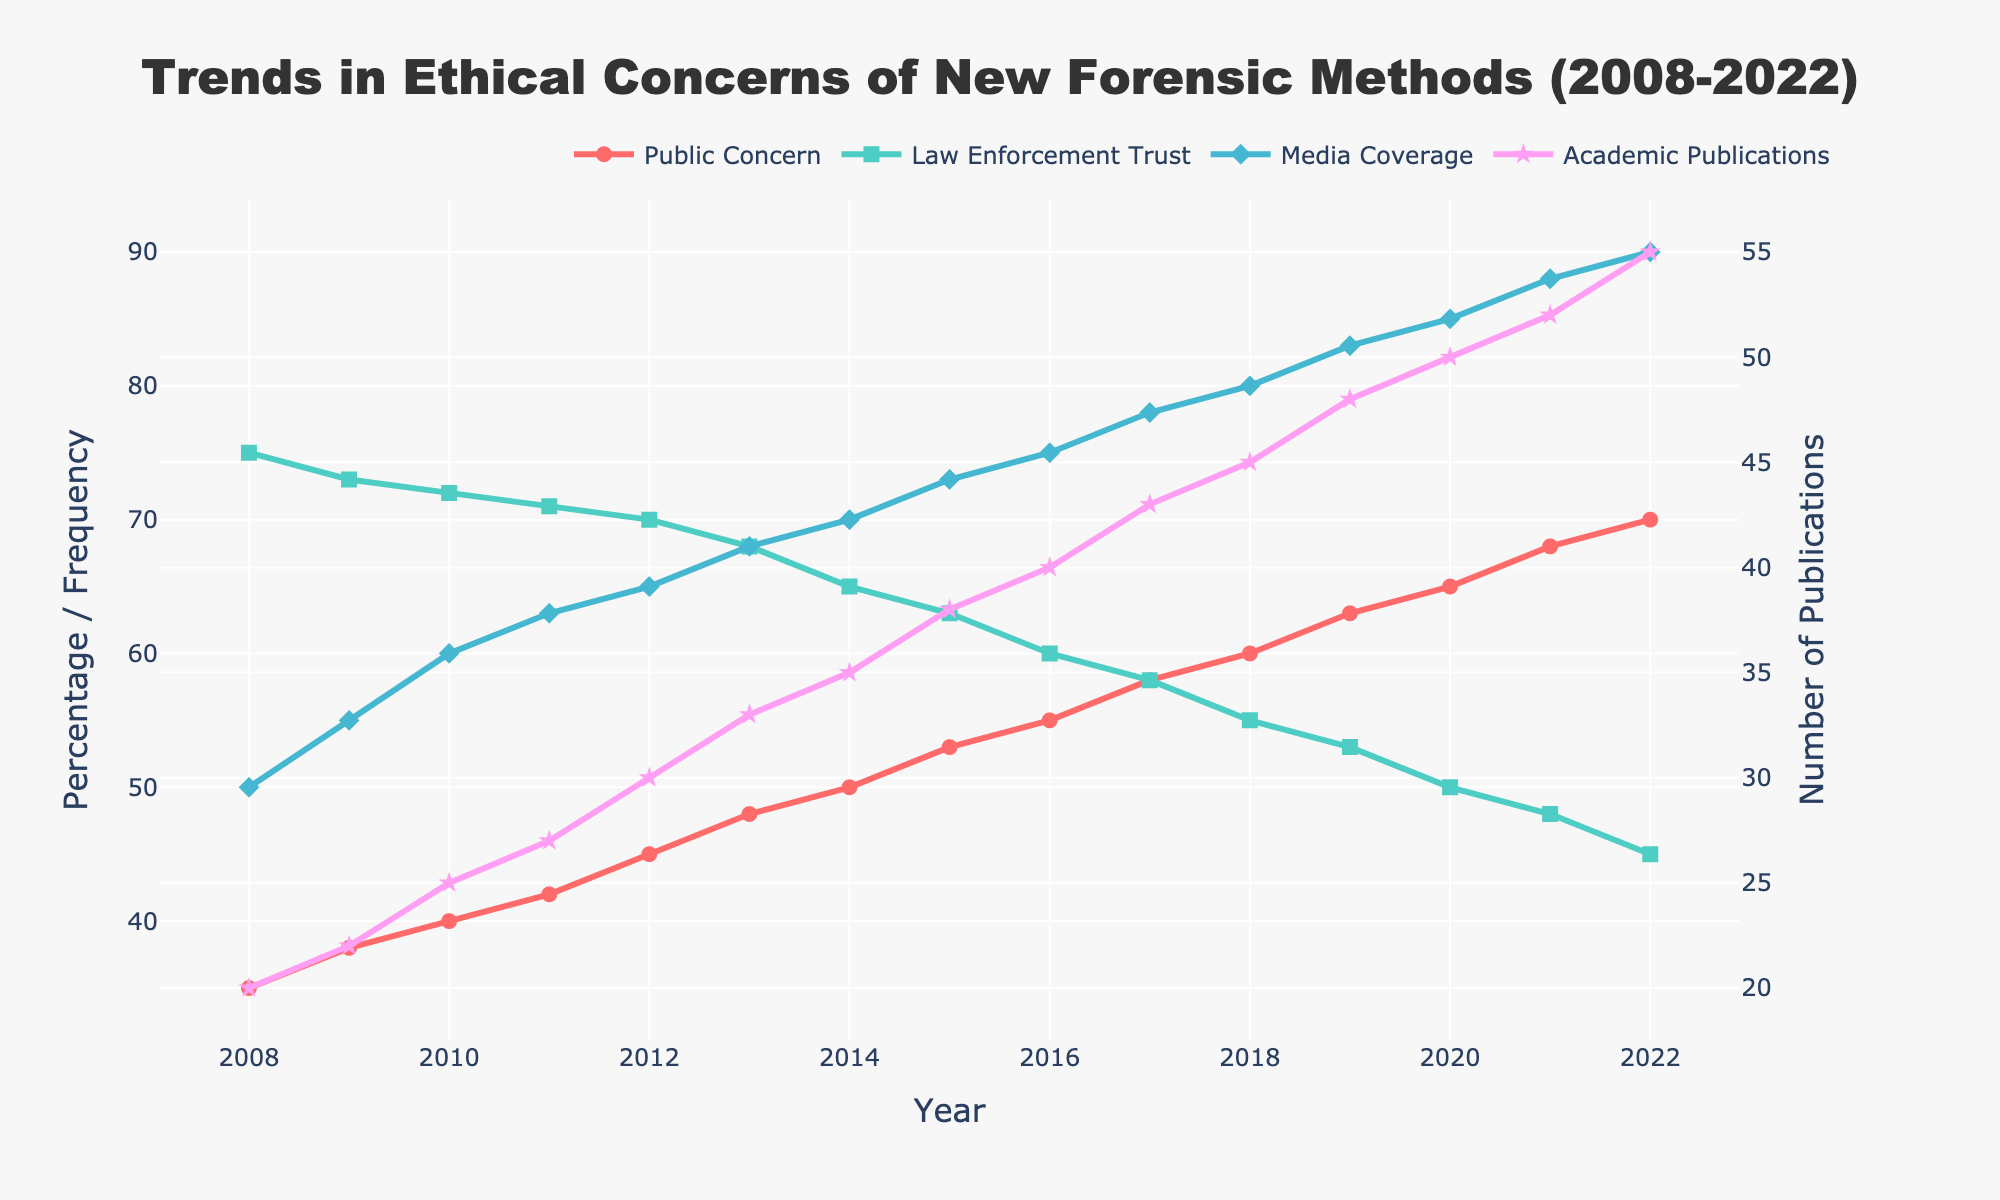what is the title of the plot? The title is usually located at the top center of the figure and briefly describes the plot's content. The title in this figure reads "Trends in Ethical Concerns of New Forensic Methods (2008-2022)."
Answer: Trends in Ethical Concerns of New Forensic Methods (2008-2022) what colors represent the different data series? Colors help distinguish different data series. The colors used are Red for Public Concern, Teal for Law Enforcement Trust, Light Blue for Media Coverage, and Pink for Academic Publications.
Answer: Red, Teal, Light Blue, and Pink what is the percentage of Law Enforcement Trust in 2020? Find the data point at "2020" on the x-axis and look at its corresponding value on the "Law Enforcement Trust" line, which is around 50.
Answer: 50 how did Media Coverage Frequency change from 2010 to 2015? From 2010 to 2015, identify the Media Coverage data points and calculate the difference: 55 in 2010 and 73 in 2015, so it increased by 18.
Answer: Increased by 18 how do General Public Concern and Law Enforcement Trust trends compare over the years? The General Public Concern shows an upward trend from 35 in 2008 to 70 in 2022, while Law Enforcement Trust shows a downward trend from 75 in 2008 to 45 in 2022.
Answer: Public Concern upward, Trust downward what is the average number of Academic Publications from 2008 to 2022? Sum all the values for Academic Publications from 2008 to 2022 and divide by the number of years (15). Sum of values is 545: (20+22+25+27+30+33+35+38+40+43+45+48+50+52+55)/15 ≈ 36.33.
Answer: Approximately 36.33 which year had the highest Media Coverage Frequency? Identify the highest point on the Media Coverage line and check the corresponding year. The peak is at 90 in 2022.
Answer: 2022 how did the trend of Academic Publications compare to Media Coverage after 2016? Both Media Coverage and Academic Publications exhibit an upward trend after 2016, but Media Coverage increases faster from 75 in 2016 to 90 in 2022, while Academic Publications increase gradually from 40 in 2016 to 55 in 2022.
Answer: Both upward, Media Coverage faster what is the difference between the highest and lowest General Public Concern percentages? Max General Public Concern is 70 in 2022 and the min is 35 in 2008. The difference is 70 - 35 = 35.
Answer: 35 how many times did Law Enforcement Trust decrease over the 15-year period? Count the years when the Law Enforcement Trust value is lower than the preceding year. It decreased in 9 instances: 2009, 2010, 2011, 2012, 2013, 2014, 2015, 2016, 2017.
Answer: 9 